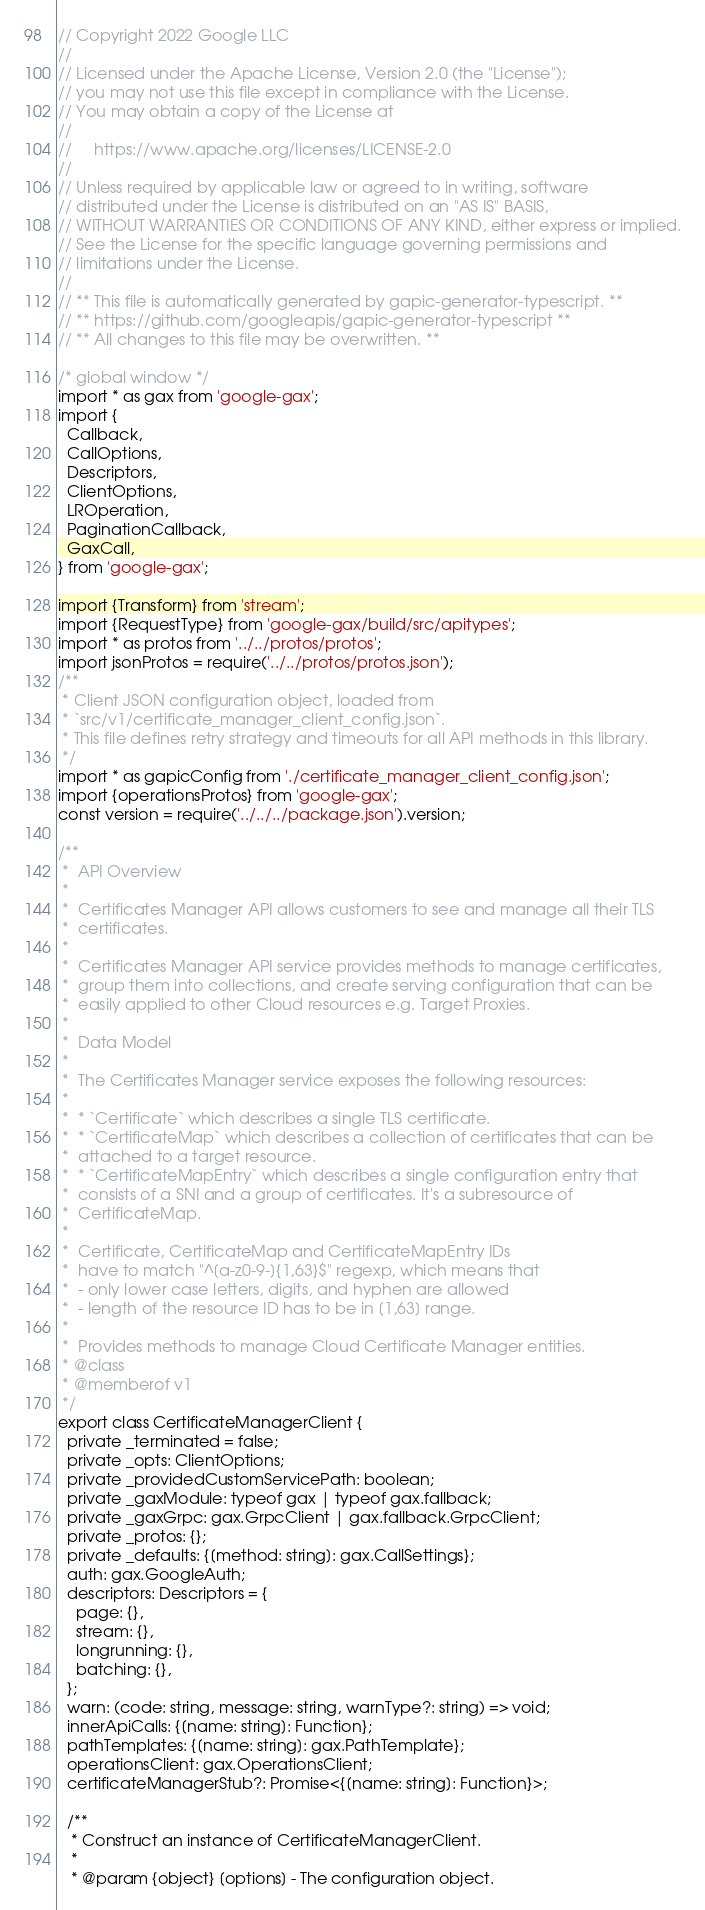<code> <loc_0><loc_0><loc_500><loc_500><_TypeScript_>// Copyright 2022 Google LLC
//
// Licensed under the Apache License, Version 2.0 (the "License");
// you may not use this file except in compliance with the License.
// You may obtain a copy of the License at
//
//     https://www.apache.org/licenses/LICENSE-2.0
//
// Unless required by applicable law or agreed to in writing, software
// distributed under the License is distributed on an "AS IS" BASIS,
// WITHOUT WARRANTIES OR CONDITIONS OF ANY KIND, either express or implied.
// See the License for the specific language governing permissions and
// limitations under the License.
//
// ** This file is automatically generated by gapic-generator-typescript. **
// ** https://github.com/googleapis/gapic-generator-typescript **
// ** All changes to this file may be overwritten. **

/* global window */
import * as gax from 'google-gax';
import {
  Callback,
  CallOptions,
  Descriptors,
  ClientOptions,
  LROperation,
  PaginationCallback,
  GaxCall,
} from 'google-gax';

import {Transform} from 'stream';
import {RequestType} from 'google-gax/build/src/apitypes';
import * as protos from '../../protos/protos';
import jsonProtos = require('../../protos/protos.json');
/**
 * Client JSON configuration object, loaded from
 * `src/v1/certificate_manager_client_config.json`.
 * This file defines retry strategy and timeouts for all API methods in this library.
 */
import * as gapicConfig from './certificate_manager_client_config.json';
import {operationsProtos} from 'google-gax';
const version = require('../../../package.json').version;

/**
 *  API Overview
 *
 *  Certificates Manager API allows customers to see and manage all their TLS
 *  certificates.
 *
 *  Certificates Manager API service provides methods to manage certificates,
 *  group them into collections, and create serving configuration that can be
 *  easily applied to other Cloud resources e.g. Target Proxies.
 *
 *  Data Model
 *
 *  The Certificates Manager service exposes the following resources:
 *
 *  * `Certificate` which describes a single TLS certificate.
 *  * `CertificateMap` which describes a collection of certificates that can be
 *  attached to a target resource.
 *  * `CertificateMapEntry` which describes a single configuration entry that
 *  consists of a SNI and a group of certificates. It's a subresource of
 *  CertificateMap.
 *
 *  Certificate, CertificateMap and CertificateMapEntry IDs
 *  have to match "^[a-z0-9-]{1,63}$" regexp, which means that
 *  - only lower case letters, digits, and hyphen are allowed
 *  - length of the resource ID has to be in [1,63] range.
 *
 *  Provides methods to manage Cloud Certificate Manager entities.
 * @class
 * @memberof v1
 */
export class CertificateManagerClient {
  private _terminated = false;
  private _opts: ClientOptions;
  private _providedCustomServicePath: boolean;
  private _gaxModule: typeof gax | typeof gax.fallback;
  private _gaxGrpc: gax.GrpcClient | gax.fallback.GrpcClient;
  private _protos: {};
  private _defaults: {[method: string]: gax.CallSettings};
  auth: gax.GoogleAuth;
  descriptors: Descriptors = {
    page: {},
    stream: {},
    longrunning: {},
    batching: {},
  };
  warn: (code: string, message: string, warnType?: string) => void;
  innerApiCalls: {[name: string]: Function};
  pathTemplates: {[name: string]: gax.PathTemplate};
  operationsClient: gax.OperationsClient;
  certificateManagerStub?: Promise<{[name: string]: Function}>;

  /**
   * Construct an instance of CertificateManagerClient.
   *
   * @param {object} [options] - The configuration object.</code> 